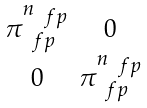Convert formula to latex. <formula><loc_0><loc_0><loc_500><loc_500>\begin{smallmatrix} \pi _ { \ f p } ^ { n _ { \ f p } } & 0 \\ 0 & \pi _ { \ f p } ^ { n _ { \ f p } } \end{smallmatrix}</formula> 